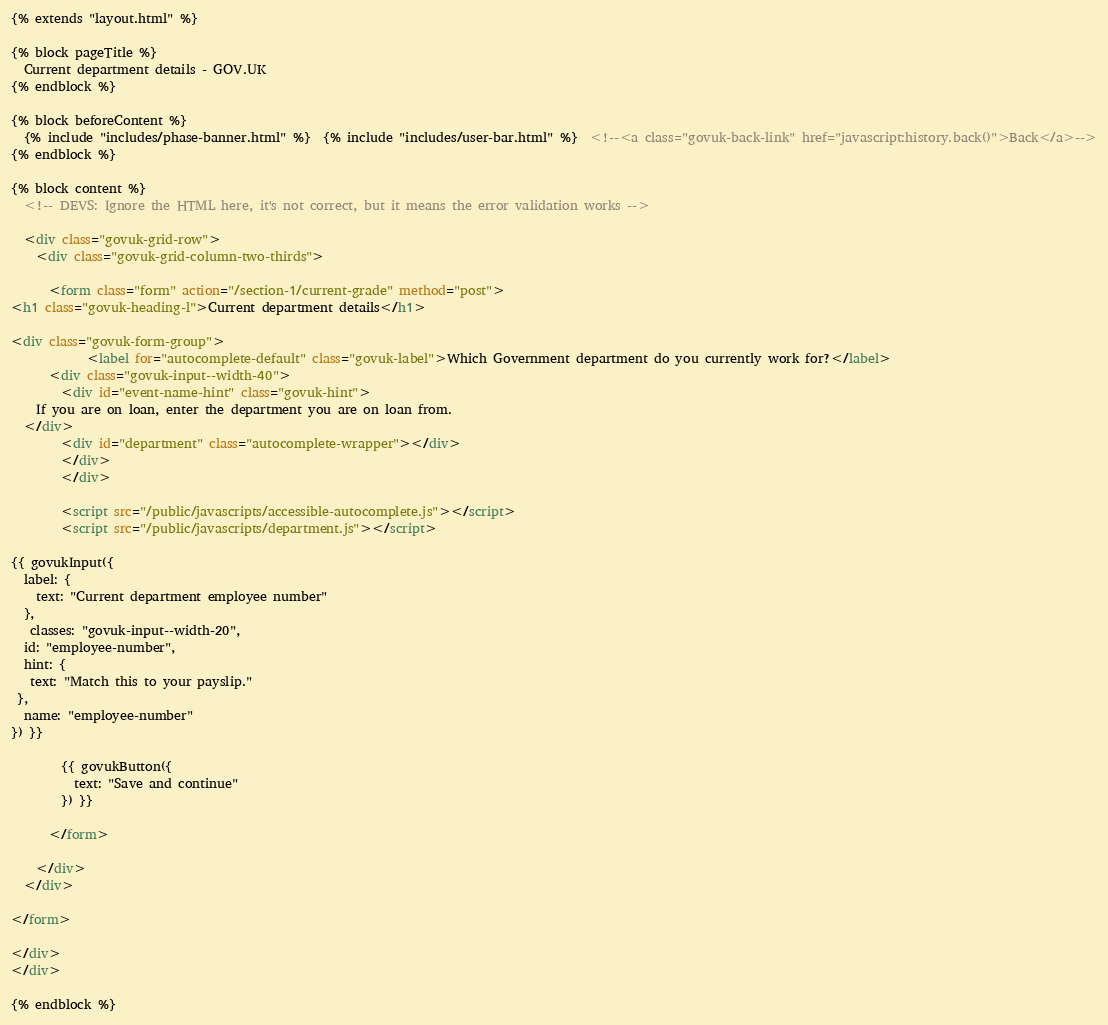<code> <loc_0><loc_0><loc_500><loc_500><_HTML_>{% extends "layout.html" %}

{% block pageTitle %}
  Current department details - GOV.UK
{% endblock %}

{% block beforeContent %}
  {% include "includes/phase-banner.html" %}  {% include "includes/user-bar.html" %}  <!--<a class="govuk-back-link" href="javascript:history.back()">Back</a>-->
{% endblock %}

{% block content %}
  <!-- DEVS: Ignore the HTML here, it's not correct, but it means the error validation works -->

  <div class="govuk-grid-row">
    <div class="govuk-grid-column-two-thirds">

      <form class="form" action="/section-1/current-grade" method="post">
<h1 class="govuk-heading-l">Current department details</h1>

<div class="govuk-form-group">
            <label for="autocomplete-default" class="govuk-label">Which Government department do you currently work for?</label>
      <div class="govuk-input--width-40">
        <div id="event-name-hint" class="govuk-hint">
    If you are on loan, enter the department you are on loan from.
  </div>
        <div id="department" class="autocomplete-wrapper"></div>
        </div>
        </div>

        <script src="/public/javascripts/accessible-autocomplete.js"></script>
        <script src="/public/javascripts/department.js"></script>

{{ govukInput({
  label: {
    text: "Current department employee number"
  },
   classes: "govuk-input--width-20",
  id: "employee-number",
  hint: {
   text: "Match this to your payslip."
 },
  name: "employee-number"
}) }}

        {{ govukButton({
          text: "Save and continue"
        }) }}

      </form>

    </div>
  </div>

</form>

</div>
</div>

{% endblock %}
</code> 